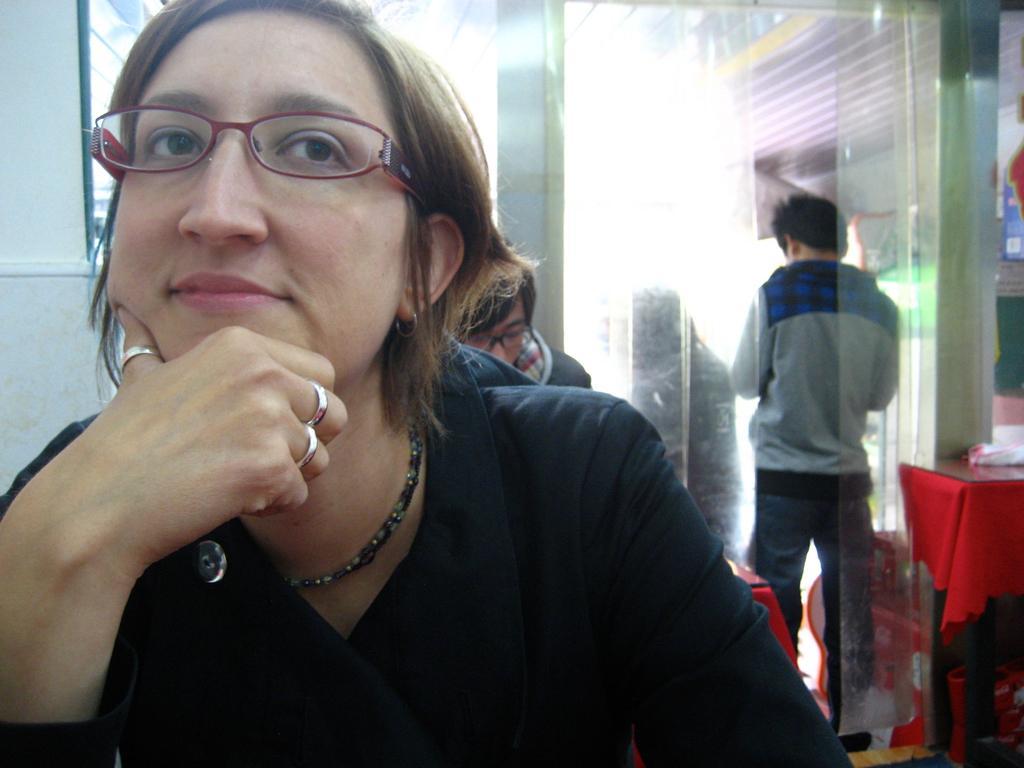Could you give a brief overview of what you see in this image? In this image, we can see a woman sitting, she is wearing specs, in the background, we can see a person sitting and there is a man standing, we can see a table covered with a red cloth. 